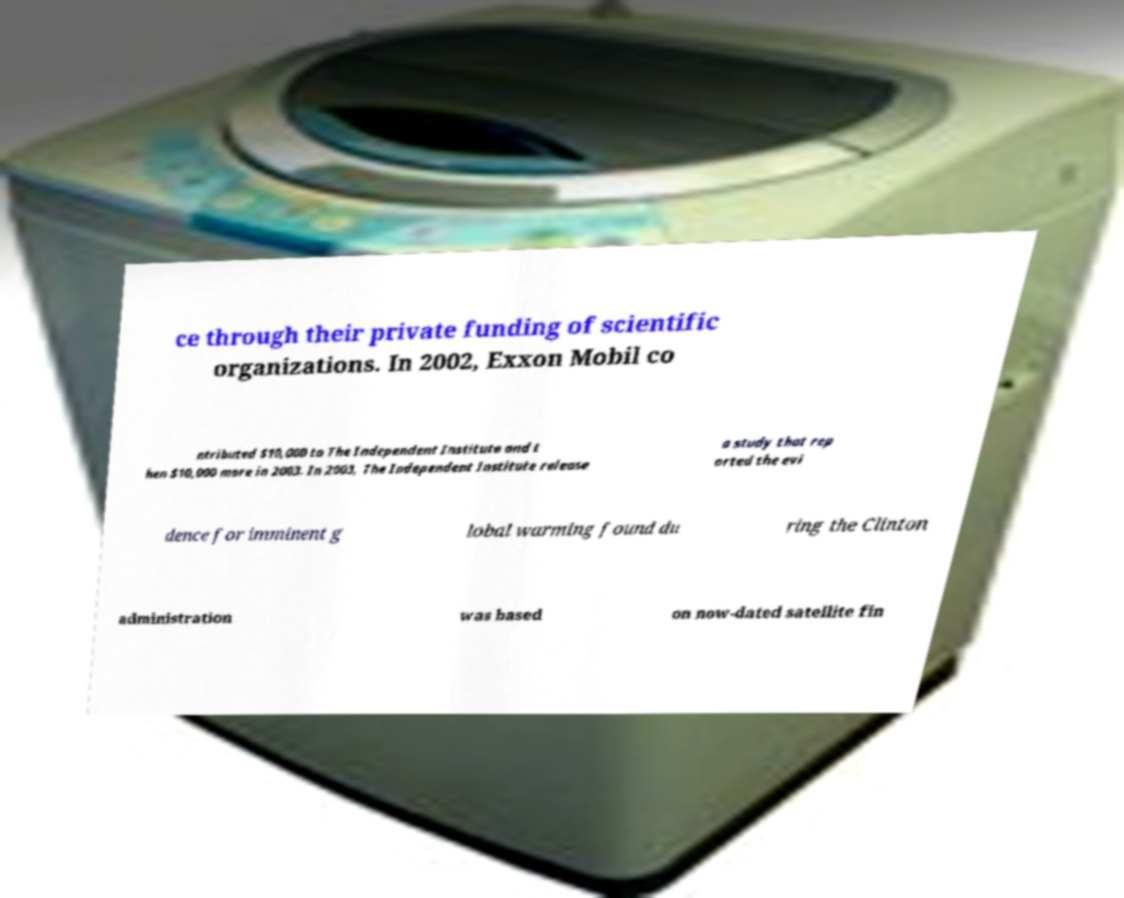There's text embedded in this image that I need extracted. Can you transcribe it verbatim? ce through their private funding of scientific organizations. In 2002, Exxon Mobil co ntributed $10,000 to The Independent Institute and t hen $10,000 more in 2003. In 2003, The Independent Institute release a study that rep orted the evi dence for imminent g lobal warming found du ring the Clinton administration was based on now-dated satellite fin 